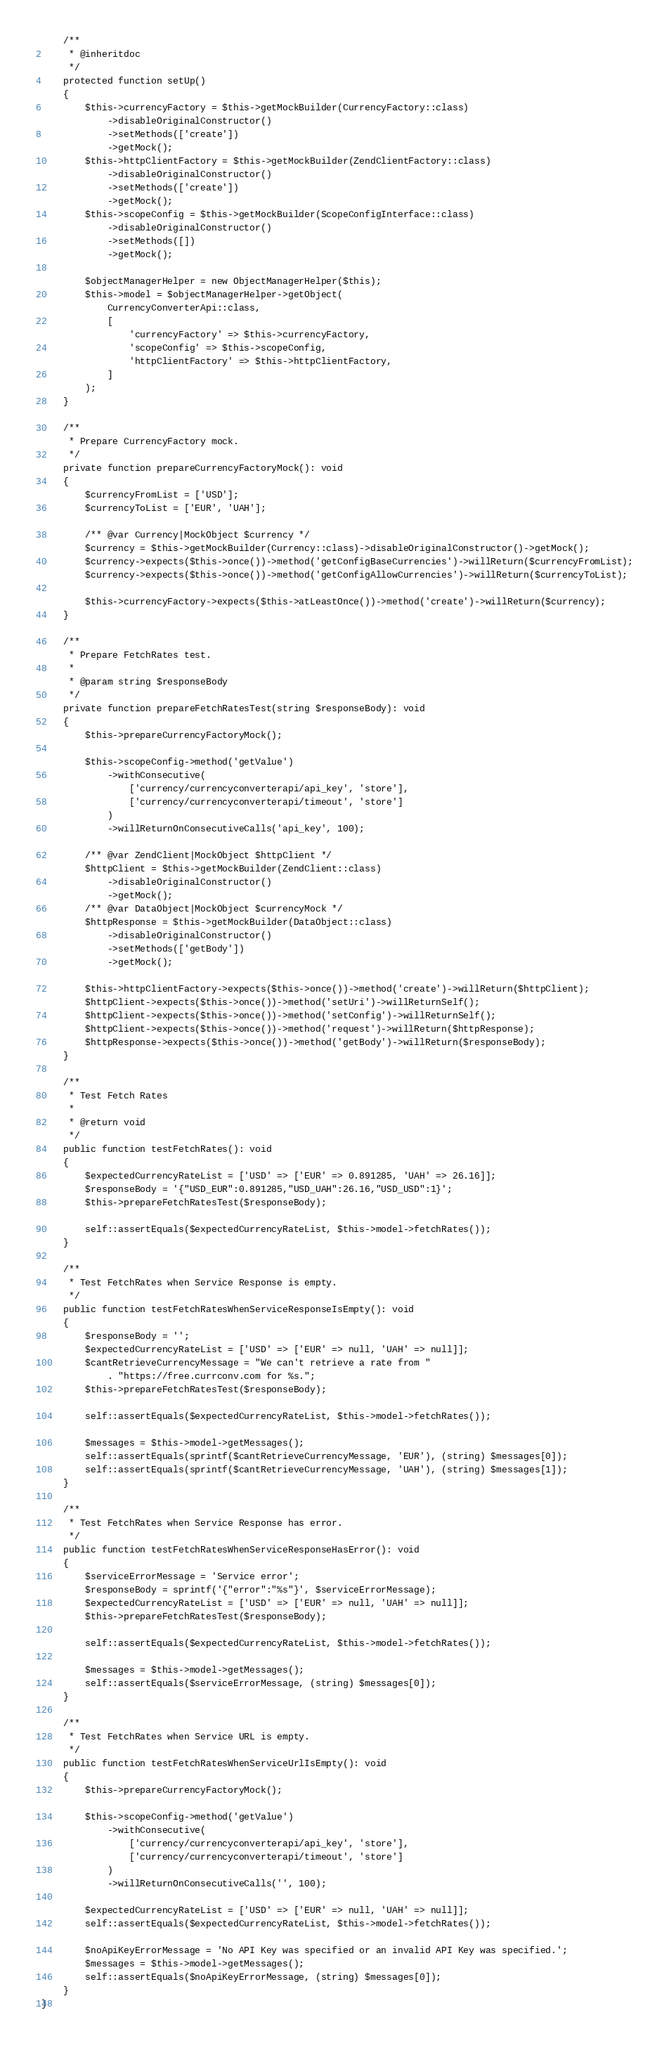Convert code to text. <code><loc_0><loc_0><loc_500><loc_500><_PHP_>    /**
     * @inheritdoc
     */
    protected function setUp()
    {
        $this->currencyFactory = $this->getMockBuilder(CurrencyFactory::class)
            ->disableOriginalConstructor()
            ->setMethods(['create'])
            ->getMock();
        $this->httpClientFactory = $this->getMockBuilder(ZendClientFactory::class)
            ->disableOriginalConstructor()
            ->setMethods(['create'])
            ->getMock();
        $this->scopeConfig = $this->getMockBuilder(ScopeConfigInterface::class)
            ->disableOriginalConstructor()
            ->setMethods([])
            ->getMock();

        $objectManagerHelper = new ObjectManagerHelper($this);
        $this->model = $objectManagerHelper->getObject(
            CurrencyConverterApi::class,
            [
                'currencyFactory' => $this->currencyFactory,
                'scopeConfig' => $this->scopeConfig,
                'httpClientFactory' => $this->httpClientFactory,
            ]
        );
    }

    /**
     * Prepare CurrencyFactory mock.
     */
    private function prepareCurrencyFactoryMock(): void
    {
        $currencyFromList = ['USD'];
        $currencyToList = ['EUR', 'UAH'];

        /** @var Currency|MockObject $currency */
        $currency = $this->getMockBuilder(Currency::class)->disableOriginalConstructor()->getMock();
        $currency->expects($this->once())->method('getConfigBaseCurrencies')->willReturn($currencyFromList);
        $currency->expects($this->once())->method('getConfigAllowCurrencies')->willReturn($currencyToList);

        $this->currencyFactory->expects($this->atLeastOnce())->method('create')->willReturn($currency);
    }

    /**
     * Prepare FetchRates test.
     *
     * @param string $responseBody
     */
    private function prepareFetchRatesTest(string $responseBody): void
    {
        $this->prepareCurrencyFactoryMock();

        $this->scopeConfig->method('getValue')
            ->withConsecutive(
                ['currency/currencyconverterapi/api_key', 'store'],
                ['currency/currencyconverterapi/timeout', 'store']
            )
            ->willReturnOnConsecutiveCalls('api_key', 100);

        /** @var ZendClient|MockObject $httpClient */
        $httpClient = $this->getMockBuilder(ZendClient::class)
            ->disableOriginalConstructor()
            ->getMock();
        /** @var DataObject|MockObject $currencyMock */
        $httpResponse = $this->getMockBuilder(DataObject::class)
            ->disableOriginalConstructor()
            ->setMethods(['getBody'])
            ->getMock();

        $this->httpClientFactory->expects($this->once())->method('create')->willReturn($httpClient);
        $httpClient->expects($this->once())->method('setUri')->willReturnSelf();
        $httpClient->expects($this->once())->method('setConfig')->willReturnSelf();
        $httpClient->expects($this->once())->method('request')->willReturn($httpResponse);
        $httpResponse->expects($this->once())->method('getBody')->willReturn($responseBody);
    }

    /**
     * Test Fetch Rates
     *
     * @return void
     */
    public function testFetchRates(): void
    {
        $expectedCurrencyRateList = ['USD' => ['EUR' => 0.891285, 'UAH' => 26.16]];
        $responseBody = '{"USD_EUR":0.891285,"USD_UAH":26.16,"USD_USD":1}';
        $this->prepareFetchRatesTest($responseBody);

        self::assertEquals($expectedCurrencyRateList, $this->model->fetchRates());
    }

    /**
     * Test FetchRates when Service Response is empty.
     */
    public function testFetchRatesWhenServiceResponseIsEmpty(): void
    {
        $responseBody = '';
        $expectedCurrencyRateList = ['USD' => ['EUR' => null, 'UAH' => null]];
        $cantRetrieveCurrencyMessage = "We can't retrieve a rate from "
            . "https://free.currconv.com for %s.";
        $this->prepareFetchRatesTest($responseBody);

        self::assertEquals($expectedCurrencyRateList, $this->model->fetchRates());

        $messages = $this->model->getMessages();
        self::assertEquals(sprintf($cantRetrieveCurrencyMessage, 'EUR'), (string) $messages[0]);
        self::assertEquals(sprintf($cantRetrieveCurrencyMessage, 'UAH'), (string) $messages[1]);
    }

    /**
     * Test FetchRates when Service Response has error.
     */
    public function testFetchRatesWhenServiceResponseHasError(): void
    {
        $serviceErrorMessage = 'Service error';
        $responseBody = sprintf('{"error":"%s"}', $serviceErrorMessage);
        $expectedCurrencyRateList = ['USD' => ['EUR' => null, 'UAH' => null]];
        $this->prepareFetchRatesTest($responseBody);

        self::assertEquals($expectedCurrencyRateList, $this->model->fetchRates());

        $messages = $this->model->getMessages();
        self::assertEquals($serviceErrorMessage, (string) $messages[0]);
    }

    /**
     * Test FetchRates when Service URL is empty.
     */
    public function testFetchRatesWhenServiceUrlIsEmpty(): void
    {
        $this->prepareCurrencyFactoryMock();

        $this->scopeConfig->method('getValue')
            ->withConsecutive(
                ['currency/currencyconverterapi/api_key', 'store'],
                ['currency/currencyconverterapi/timeout', 'store']
            )
            ->willReturnOnConsecutiveCalls('', 100);

        $expectedCurrencyRateList = ['USD' => ['EUR' => null, 'UAH' => null]];
        self::assertEquals($expectedCurrencyRateList, $this->model->fetchRates());

        $noApiKeyErrorMessage = 'No API Key was specified or an invalid API Key was specified.';
        $messages = $this->model->getMessages();
        self::assertEquals($noApiKeyErrorMessage, (string) $messages[0]);
    }
}
</code> 